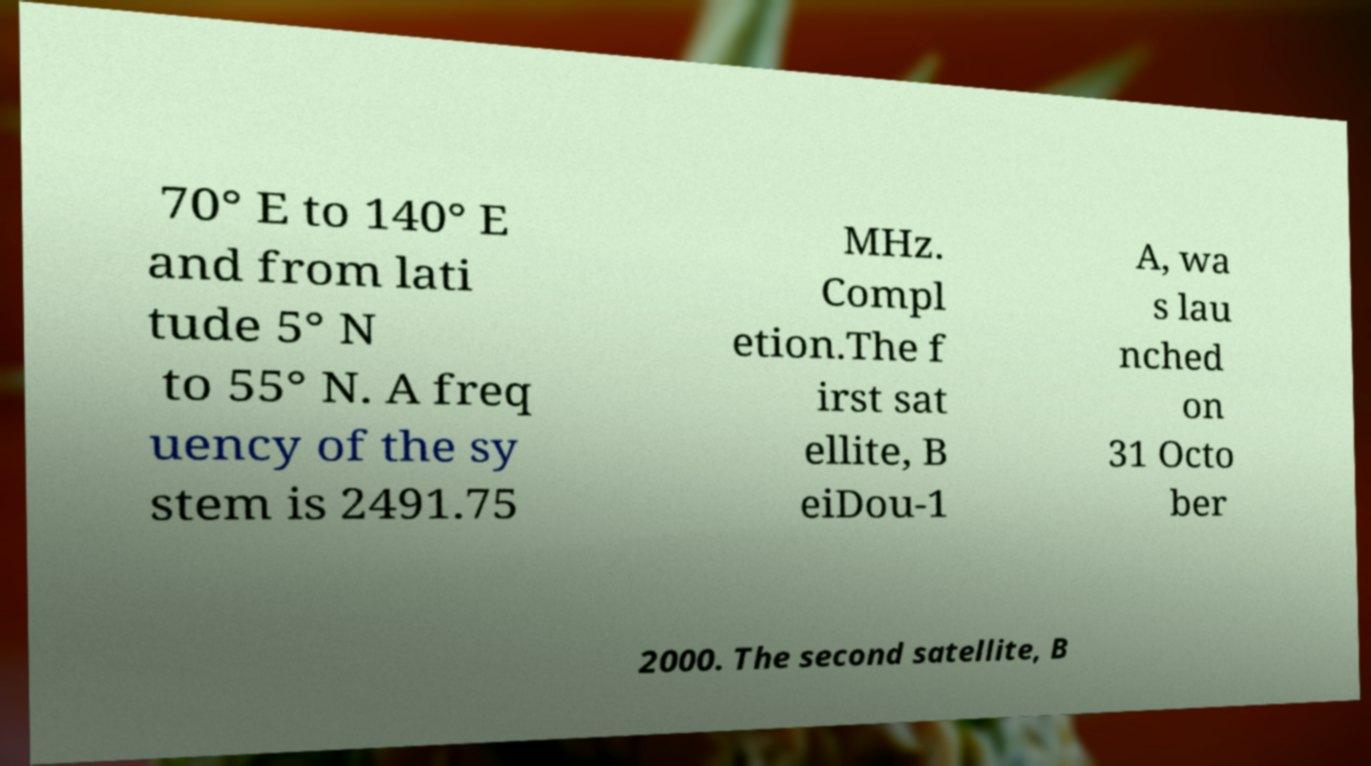I need the written content from this picture converted into text. Can you do that? 70° E to 140° E and from lati tude 5° N to 55° N. A freq uency of the sy stem is 2491.75 MHz. Compl etion.The f irst sat ellite, B eiDou-1 A, wa s lau nched on 31 Octo ber 2000. The second satellite, B 